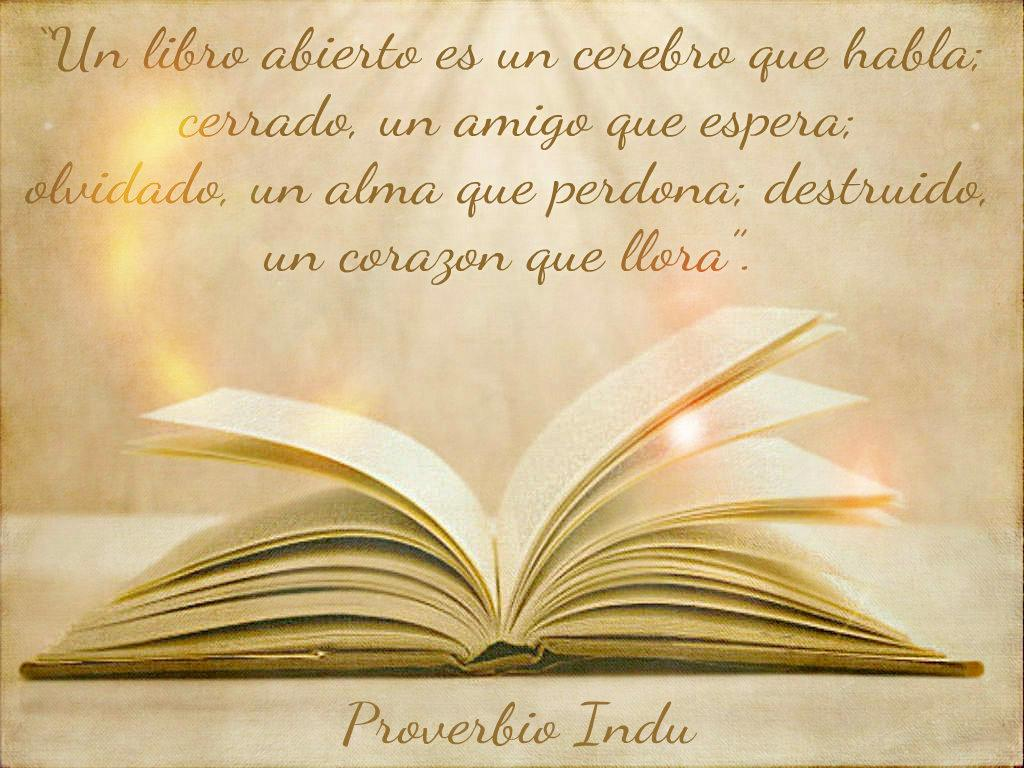<image>
Present a compact description of the photo's key features. A image of a book flipping pages and above it is a Indian proverb. 